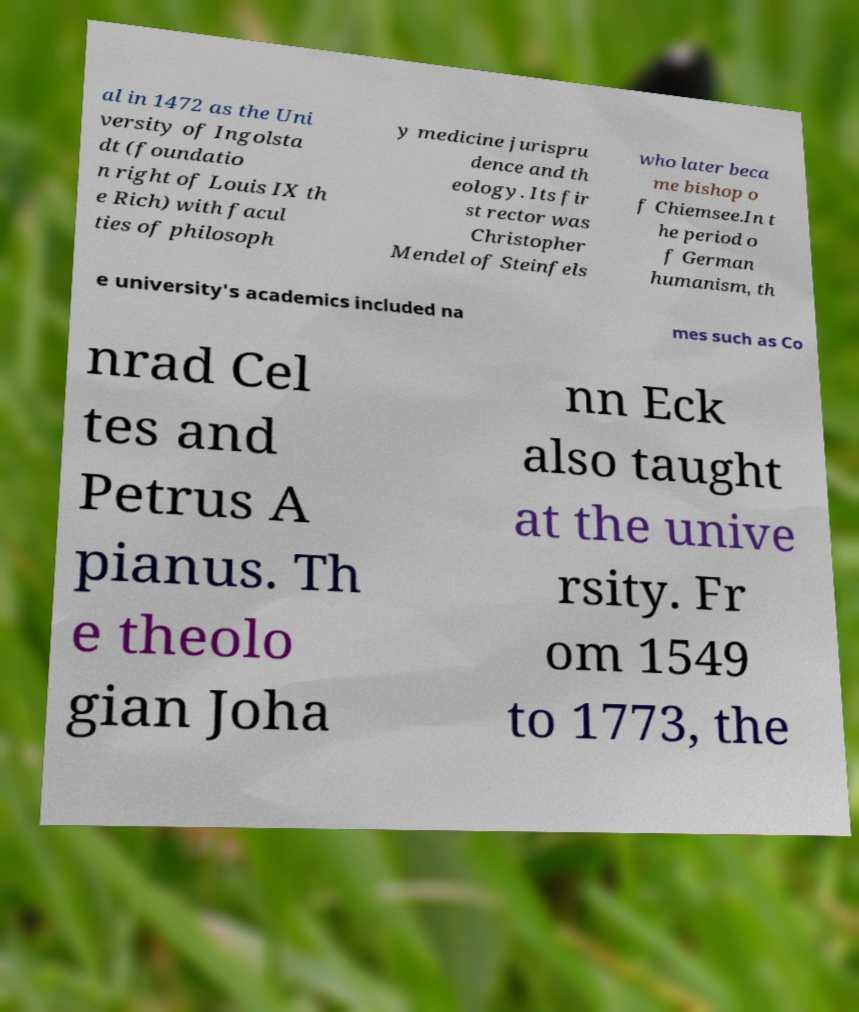I need the written content from this picture converted into text. Can you do that? al in 1472 as the Uni versity of Ingolsta dt (foundatio n right of Louis IX th e Rich) with facul ties of philosoph y medicine jurispru dence and th eology. Its fir st rector was Christopher Mendel of Steinfels who later beca me bishop o f Chiemsee.In t he period o f German humanism, th e university's academics included na mes such as Co nrad Cel tes and Petrus A pianus. Th e theolo gian Joha nn Eck also taught at the unive rsity. Fr om 1549 to 1773, the 